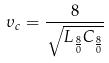<formula> <loc_0><loc_0><loc_500><loc_500>\upsilon _ { c } = \frac { 8 } { \sqrt { L _ { \frac { 8 } { 0 } } C _ { \frac { 8 } { 0 } } } }</formula> 